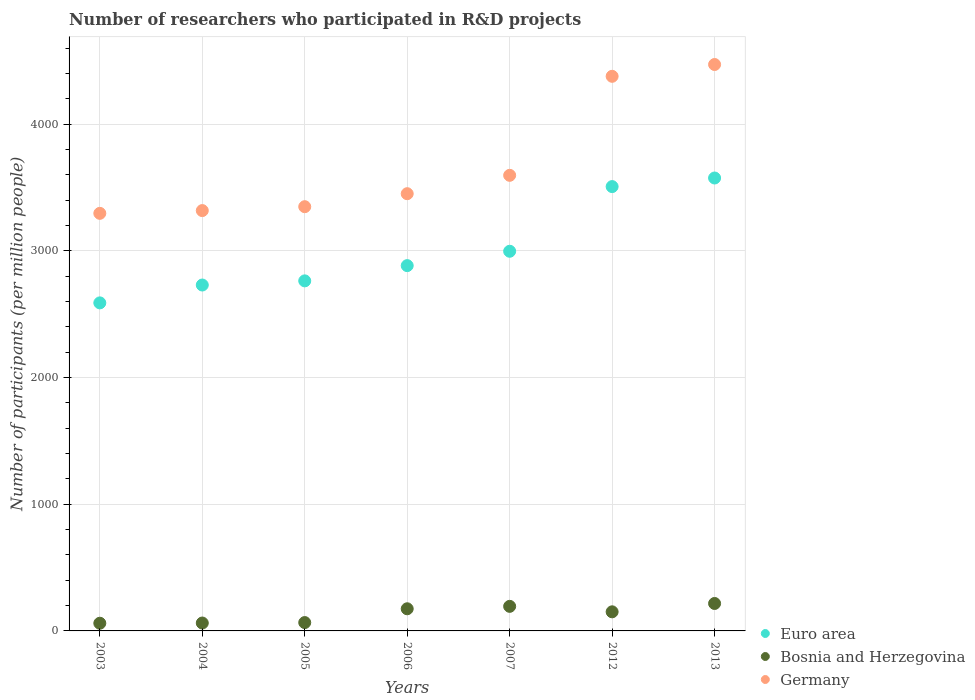Is the number of dotlines equal to the number of legend labels?
Give a very brief answer. Yes. What is the number of researchers who participated in R&D projects in Euro area in 2012?
Ensure brevity in your answer.  3508.32. Across all years, what is the maximum number of researchers who participated in R&D projects in Germany?
Make the answer very short. 4472.24. Across all years, what is the minimum number of researchers who participated in R&D projects in Euro area?
Ensure brevity in your answer.  2590.14. What is the total number of researchers who participated in R&D projects in Germany in the graph?
Your answer should be very brief. 2.59e+04. What is the difference between the number of researchers who participated in R&D projects in Bosnia and Herzegovina in 2007 and that in 2012?
Your answer should be compact. 43.24. What is the difference between the number of researchers who participated in R&D projects in Germany in 2005 and the number of researchers who participated in R&D projects in Bosnia and Herzegovina in 2012?
Offer a terse response. 3198.85. What is the average number of researchers who participated in R&D projects in Germany per year?
Your answer should be very brief. 3695.2. In the year 2005, what is the difference between the number of researchers who participated in R&D projects in Germany and number of researchers who participated in R&D projects in Euro area?
Your answer should be very brief. 585.67. In how many years, is the number of researchers who participated in R&D projects in Euro area greater than 2400?
Make the answer very short. 7. What is the ratio of the number of researchers who participated in R&D projects in Germany in 2005 to that in 2006?
Ensure brevity in your answer.  0.97. What is the difference between the highest and the second highest number of researchers who participated in R&D projects in Germany?
Keep it short and to the point. 93.17. What is the difference between the highest and the lowest number of researchers who participated in R&D projects in Euro area?
Your answer should be compact. 986.01. In how many years, is the number of researchers who participated in R&D projects in Germany greater than the average number of researchers who participated in R&D projects in Germany taken over all years?
Your answer should be compact. 2. Does the number of researchers who participated in R&D projects in Bosnia and Herzegovina monotonically increase over the years?
Your answer should be very brief. No. What is the difference between two consecutive major ticks on the Y-axis?
Provide a succinct answer. 1000. Are the values on the major ticks of Y-axis written in scientific E-notation?
Offer a very short reply. No. What is the title of the graph?
Your answer should be very brief. Number of researchers who participated in R&D projects. Does "Turks and Caicos Islands" appear as one of the legend labels in the graph?
Make the answer very short. No. What is the label or title of the X-axis?
Keep it short and to the point. Years. What is the label or title of the Y-axis?
Make the answer very short. Number of participants (per million people). What is the Number of participants (per million people) in Euro area in 2003?
Your response must be concise. 2590.14. What is the Number of participants (per million people) of Bosnia and Herzegovina in 2003?
Make the answer very short. 60.7. What is the Number of participants (per million people) of Germany in 2003?
Keep it short and to the point. 3297.09. What is the Number of participants (per million people) of Euro area in 2004?
Keep it short and to the point. 2731.18. What is the Number of participants (per million people) of Bosnia and Herzegovina in 2004?
Your answer should be compact. 62.41. What is the Number of participants (per million people) in Germany in 2004?
Provide a succinct answer. 3318.87. What is the Number of participants (per million people) in Euro area in 2005?
Offer a terse response. 2763.98. What is the Number of participants (per million people) of Bosnia and Herzegovina in 2005?
Your response must be concise. 65.95. What is the Number of participants (per million people) of Germany in 2005?
Make the answer very short. 3349.65. What is the Number of participants (per million people) of Euro area in 2006?
Make the answer very short. 2884.31. What is the Number of participants (per million people) of Bosnia and Herzegovina in 2006?
Make the answer very short. 174.84. What is the Number of participants (per million people) of Germany in 2006?
Your answer should be compact. 3452.21. What is the Number of participants (per million people) in Euro area in 2007?
Give a very brief answer. 2997.7. What is the Number of participants (per million people) of Bosnia and Herzegovina in 2007?
Make the answer very short. 194.03. What is the Number of participants (per million people) in Germany in 2007?
Provide a succinct answer. 3597.24. What is the Number of participants (per million people) in Euro area in 2012?
Give a very brief answer. 3508.32. What is the Number of participants (per million people) of Bosnia and Herzegovina in 2012?
Make the answer very short. 150.79. What is the Number of participants (per million people) in Germany in 2012?
Offer a very short reply. 4379.08. What is the Number of participants (per million people) in Euro area in 2013?
Your response must be concise. 3576.15. What is the Number of participants (per million people) of Bosnia and Herzegovina in 2013?
Provide a short and direct response. 216.68. What is the Number of participants (per million people) of Germany in 2013?
Your response must be concise. 4472.24. Across all years, what is the maximum Number of participants (per million people) of Euro area?
Make the answer very short. 3576.15. Across all years, what is the maximum Number of participants (per million people) in Bosnia and Herzegovina?
Your answer should be compact. 216.68. Across all years, what is the maximum Number of participants (per million people) of Germany?
Your response must be concise. 4472.24. Across all years, what is the minimum Number of participants (per million people) of Euro area?
Offer a very short reply. 2590.14. Across all years, what is the minimum Number of participants (per million people) in Bosnia and Herzegovina?
Offer a terse response. 60.7. Across all years, what is the minimum Number of participants (per million people) in Germany?
Keep it short and to the point. 3297.09. What is the total Number of participants (per million people) of Euro area in the graph?
Offer a terse response. 2.11e+04. What is the total Number of participants (per million people) of Bosnia and Herzegovina in the graph?
Provide a succinct answer. 925.41. What is the total Number of participants (per million people) of Germany in the graph?
Your response must be concise. 2.59e+04. What is the difference between the Number of participants (per million people) in Euro area in 2003 and that in 2004?
Keep it short and to the point. -141.05. What is the difference between the Number of participants (per million people) of Bosnia and Herzegovina in 2003 and that in 2004?
Give a very brief answer. -1.7. What is the difference between the Number of participants (per million people) of Germany in 2003 and that in 2004?
Your answer should be compact. -21.78. What is the difference between the Number of participants (per million people) of Euro area in 2003 and that in 2005?
Keep it short and to the point. -173.85. What is the difference between the Number of participants (per million people) of Bosnia and Herzegovina in 2003 and that in 2005?
Ensure brevity in your answer.  -5.25. What is the difference between the Number of participants (per million people) in Germany in 2003 and that in 2005?
Offer a terse response. -52.55. What is the difference between the Number of participants (per million people) in Euro area in 2003 and that in 2006?
Provide a succinct answer. -294.17. What is the difference between the Number of participants (per million people) in Bosnia and Herzegovina in 2003 and that in 2006?
Your response must be concise. -114.14. What is the difference between the Number of participants (per million people) of Germany in 2003 and that in 2006?
Provide a succinct answer. -155.12. What is the difference between the Number of participants (per million people) in Euro area in 2003 and that in 2007?
Ensure brevity in your answer.  -407.56. What is the difference between the Number of participants (per million people) in Bosnia and Herzegovina in 2003 and that in 2007?
Provide a short and direct response. -133.33. What is the difference between the Number of participants (per million people) in Germany in 2003 and that in 2007?
Give a very brief answer. -300.15. What is the difference between the Number of participants (per million people) in Euro area in 2003 and that in 2012?
Ensure brevity in your answer.  -918.19. What is the difference between the Number of participants (per million people) of Bosnia and Herzegovina in 2003 and that in 2012?
Keep it short and to the point. -90.09. What is the difference between the Number of participants (per million people) of Germany in 2003 and that in 2012?
Your answer should be very brief. -1081.98. What is the difference between the Number of participants (per million people) in Euro area in 2003 and that in 2013?
Your response must be concise. -986.01. What is the difference between the Number of participants (per million people) of Bosnia and Herzegovina in 2003 and that in 2013?
Make the answer very short. -155.98. What is the difference between the Number of participants (per million people) of Germany in 2003 and that in 2013?
Make the answer very short. -1175.15. What is the difference between the Number of participants (per million people) of Euro area in 2004 and that in 2005?
Offer a terse response. -32.8. What is the difference between the Number of participants (per million people) of Bosnia and Herzegovina in 2004 and that in 2005?
Provide a succinct answer. -3.55. What is the difference between the Number of participants (per million people) of Germany in 2004 and that in 2005?
Offer a terse response. -30.78. What is the difference between the Number of participants (per million people) in Euro area in 2004 and that in 2006?
Provide a short and direct response. -153.13. What is the difference between the Number of participants (per million people) of Bosnia and Herzegovina in 2004 and that in 2006?
Your answer should be very brief. -112.43. What is the difference between the Number of participants (per million people) of Germany in 2004 and that in 2006?
Your answer should be compact. -133.34. What is the difference between the Number of participants (per million people) in Euro area in 2004 and that in 2007?
Ensure brevity in your answer.  -266.52. What is the difference between the Number of participants (per million people) of Bosnia and Herzegovina in 2004 and that in 2007?
Provide a short and direct response. -131.63. What is the difference between the Number of participants (per million people) in Germany in 2004 and that in 2007?
Provide a short and direct response. -278.37. What is the difference between the Number of participants (per million people) of Euro area in 2004 and that in 2012?
Provide a short and direct response. -777.14. What is the difference between the Number of participants (per million people) of Bosnia and Herzegovina in 2004 and that in 2012?
Your answer should be compact. -88.39. What is the difference between the Number of participants (per million people) of Germany in 2004 and that in 2012?
Your answer should be compact. -1060.21. What is the difference between the Number of participants (per million people) in Euro area in 2004 and that in 2013?
Your answer should be compact. -844.96. What is the difference between the Number of participants (per million people) of Bosnia and Herzegovina in 2004 and that in 2013?
Offer a terse response. -154.28. What is the difference between the Number of participants (per million people) of Germany in 2004 and that in 2013?
Make the answer very short. -1153.37. What is the difference between the Number of participants (per million people) in Euro area in 2005 and that in 2006?
Provide a succinct answer. -120.33. What is the difference between the Number of participants (per million people) of Bosnia and Herzegovina in 2005 and that in 2006?
Give a very brief answer. -108.89. What is the difference between the Number of participants (per million people) in Germany in 2005 and that in 2006?
Give a very brief answer. -102.56. What is the difference between the Number of participants (per million people) in Euro area in 2005 and that in 2007?
Make the answer very short. -233.72. What is the difference between the Number of participants (per million people) in Bosnia and Herzegovina in 2005 and that in 2007?
Your answer should be compact. -128.08. What is the difference between the Number of participants (per million people) of Germany in 2005 and that in 2007?
Give a very brief answer. -247.59. What is the difference between the Number of participants (per million people) of Euro area in 2005 and that in 2012?
Keep it short and to the point. -744.34. What is the difference between the Number of participants (per million people) of Bosnia and Herzegovina in 2005 and that in 2012?
Your answer should be very brief. -84.84. What is the difference between the Number of participants (per million people) of Germany in 2005 and that in 2012?
Provide a succinct answer. -1029.43. What is the difference between the Number of participants (per million people) of Euro area in 2005 and that in 2013?
Keep it short and to the point. -812.16. What is the difference between the Number of participants (per million people) of Bosnia and Herzegovina in 2005 and that in 2013?
Ensure brevity in your answer.  -150.73. What is the difference between the Number of participants (per million people) of Germany in 2005 and that in 2013?
Provide a succinct answer. -1122.6. What is the difference between the Number of participants (per million people) of Euro area in 2006 and that in 2007?
Provide a short and direct response. -113.39. What is the difference between the Number of participants (per million people) of Bosnia and Herzegovina in 2006 and that in 2007?
Offer a very short reply. -19.19. What is the difference between the Number of participants (per million people) of Germany in 2006 and that in 2007?
Offer a very short reply. -145.03. What is the difference between the Number of participants (per million people) of Euro area in 2006 and that in 2012?
Your response must be concise. -624.02. What is the difference between the Number of participants (per million people) of Bosnia and Herzegovina in 2006 and that in 2012?
Your answer should be very brief. 24.05. What is the difference between the Number of participants (per million people) of Germany in 2006 and that in 2012?
Your response must be concise. -926.87. What is the difference between the Number of participants (per million people) of Euro area in 2006 and that in 2013?
Your answer should be compact. -691.84. What is the difference between the Number of participants (per million people) of Bosnia and Herzegovina in 2006 and that in 2013?
Offer a very short reply. -41.84. What is the difference between the Number of participants (per million people) in Germany in 2006 and that in 2013?
Keep it short and to the point. -1020.03. What is the difference between the Number of participants (per million people) in Euro area in 2007 and that in 2012?
Your answer should be compact. -510.63. What is the difference between the Number of participants (per million people) of Bosnia and Herzegovina in 2007 and that in 2012?
Offer a very short reply. 43.24. What is the difference between the Number of participants (per million people) in Germany in 2007 and that in 2012?
Your answer should be very brief. -781.84. What is the difference between the Number of participants (per million people) in Euro area in 2007 and that in 2013?
Keep it short and to the point. -578.45. What is the difference between the Number of participants (per million people) of Bosnia and Herzegovina in 2007 and that in 2013?
Offer a very short reply. -22.65. What is the difference between the Number of participants (per million people) in Germany in 2007 and that in 2013?
Provide a succinct answer. -875. What is the difference between the Number of participants (per million people) in Euro area in 2012 and that in 2013?
Make the answer very short. -67.82. What is the difference between the Number of participants (per million people) of Bosnia and Herzegovina in 2012 and that in 2013?
Ensure brevity in your answer.  -65.89. What is the difference between the Number of participants (per million people) in Germany in 2012 and that in 2013?
Ensure brevity in your answer.  -93.17. What is the difference between the Number of participants (per million people) in Euro area in 2003 and the Number of participants (per million people) in Bosnia and Herzegovina in 2004?
Your response must be concise. 2527.73. What is the difference between the Number of participants (per million people) of Euro area in 2003 and the Number of participants (per million people) of Germany in 2004?
Offer a very short reply. -728.73. What is the difference between the Number of participants (per million people) of Bosnia and Herzegovina in 2003 and the Number of participants (per million people) of Germany in 2004?
Offer a terse response. -3258.16. What is the difference between the Number of participants (per million people) in Euro area in 2003 and the Number of participants (per million people) in Bosnia and Herzegovina in 2005?
Your response must be concise. 2524.18. What is the difference between the Number of participants (per million people) in Euro area in 2003 and the Number of participants (per million people) in Germany in 2005?
Your response must be concise. -759.51. What is the difference between the Number of participants (per million people) of Bosnia and Herzegovina in 2003 and the Number of participants (per million people) of Germany in 2005?
Offer a terse response. -3288.94. What is the difference between the Number of participants (per million people) of Euro area in 2003 and the Number of participants (per million people) of Bosnia and Herzegovina in 2006?
Your answer should be compact. 2415.3. What is the difference between the Number of participants (per million people) in Euro area in 2003 and the Number of participants (per million people) in Germany in 2006?
Your answer should be compact. -862.07. What is the difference between the Number of participants (per million people) of Bosnia and Herzegovina in 2003 and the Number of participants (per million people) of Germany in 2006?
Provide a succinct answer. -3391.51. What is the difference between the Number of participants (per million people) in Euro area in 2003 and the Number of participants (per million people) in Bosnia and Herzegovina in 2007?
Offer a very short reply. 2396.1. What is the difference between the Number of participants (per million people) in Euro area in 2003 and the Number of participants (per million people) in Germany in 2007?
Give a very brief answer. -1007.1. What is the difference between the Number of participants (per million people) in Bosnia and Herzegovina in 2003 and the Number of participants (per million people) in Germany in 2007?
Offer a very short reply. -3536.53. What is the difference between the Number of participants (per million people) in Euro area in 2003 and the Number of participants (per million people) in Bosnia and Herzegovina in 2012?
Offer a very short reply. 2439.34. What is the difference between the Number of participants (per million people) of Euro area in 2003 and the Number of participants (per million people) of Germany in 2012?
Your answer should be very brief. -1788.94. What is the difference between the Number of participants (per million people) in Bosnia and Herzegovina in 2003 and the Number of participants (per million people) in Germany in 2012?
Provide a short and direct response. -4318.37. What is the difference between the Number of participants (per million people) in Euro area in 2003 and the Number of participants (per million people) in Bosnia and Herzegovina in 2013?
Your answer should be compact. 2373.45. What is the difference between the Number of participants (per million people) in Euro area in 2003 and the Number of participants (per million people) in Germany in 2013?
Ensure brevity in your answer.  -1882.11. What is the difference between the Number of participants (per million people) of Bosnia and Herzegovina in 2003 and the Number of participants (per million people) of Germany in 2013?
Ensure brevity in your answer.  -4411.54. What is the difference between the Number of participants (per million people) in Euro area in 2004 and the Number of participants (per million people) in Bosnia and Herzegovina in 2005?
Offer a very short reply. 2665.23. What is the difference between the Number of participants (per million people) in Euro area in 2004 and the Number of participants (per million people) in Germany in 2005?
Give a very brief answer. -618.46. What is the difference between the Number of participants (per million people) in Bosnia and Herzegovina in 2004 and the Number of participants (per million people) in Germany in 2005?
Offer a terse response. -3287.24. What is the difference between the Number of participants (per million people) of Euro area in 2004 and the Number of participants (per million people) of Bosnia and Herzegovina in 2006?
Offer a very short reply. 2556.34. What is the difference between the Number of participants (per million people) of Euro area in 2004 and the Number of participants (per million people) of Germany in 2006?
Your response must be concise. -721.03. What is the difference between the Number of participants (per million people) of Bosnia and Herzegovina in 2004 and the Number of participants (per million people) of Germany in 2006?
Give a very brief answer. -3389.8. What is the difference between the Number of participants (per million people) in Euro area in 2004 and the Number of participants (per million people) in Bosnia and Herzegovina in 2007?
Keep it short and to the point. 2537.15. What is the difference between the Number of participants (per million people) in Euro area in 2004 and the Number of participants (per million people) in Germany in 2007?
Make the answer very short. -866.06. What is the difference between the Number of participants (per million people) of Bosnia and Herzegovina in 2004 and the Number of participants (per million people) of Germany in 2007?
Make the answer very short. -3534.83. What is the difference between the Number of participants (per million people) of Euro area in 2004 and the Number of participants (per million people) of Bosnia and Herzegovina in 2012?
Provide a short and direct response. 2580.39. What is the difference between the Number of participants (per million people) of Euro area in 2004 and the Number of participants (per million people) of Germany in 2012?
Keep it short and to the point. -1647.89. What is the difference between the Number of participants (per million people) of Bosnia and Herzegovina in 2004 and the Number of participants (per million people) of Germany in 2012?
Your answer should be compact. -4316.67. What is the difference between the Number of participants (per million people) of Euro area in 2004 and the Number of participants (per million people) of Bosnia and Herzegovina in 2013?
Ensure brevity in your answer.  2514.5. What is the difference between the Number of participants (per million people) in Euro area in 2004 and the Number of participants (per million people) in Germany in 2013?
Offer a terse response. -1741.06. What is the difference between the Number of participants (per million people) of Bosnia and Herzegovina in 2004 and the Number of participants (per million people) of Germany in 2013?
Make the answer very short. -4409.84. What is the difference between the Number of participants (per million people) in Euro area in 2005 and the Number of participants (per million people) in Bosnia and Herzegovina in 2006?
Make the answer very short. 2589.14. What is the difference between the Number of participants (per million people) of Euro area in 2005 and the Number of participants (per million people) of Germany in 2006?
Ensure brevity in your answer.  -688.23. What is the difference between the Number of participants (per million people) in Bosnia and Herzegovina in 2005 and the Number of participants (per million people) in Germany in 2006?
Provide a succinct answer. -3386.26. What is the difference between the Number of participants (per million people) of Euro area in 2005 and the Number of participants (per million people) of Bosnia and Herzegovina in 2007?
Keep it short and to the point. 2569.95. What is the difference between the Number of participants (per million people) in Euro area in 2005 and the Number of participants (per million people) in Germany in 2007?
Your answer should be compact. -833.26. What is the difference between the Number of participants (per million people) in Bosnia and Herzegovina in 2005 and the Number of participants (per million people) in Germany in 2007?
Offer a very short reply. -3531.29. What is the difference between the Number of participants (per million people) of Euro area in 2005 and the Number of participants (per million people) of Bosnia and Herzegovina in 2012?
Provide a short and direct response. 2613.19. What is the difference between the Number of participants (per million people) of Euro area in 2005 and the Number of participants (per million people) of Germany in 2012?
Make the answer very short. -1615.09. What is the difference between the Number of participants (per million people) of Bosnia and Herzegovina in 2005 and the Number of participants (per million people) of Germany in 2012?
Your response must be concise. -4313.12. What is the difference between the Number of participants (per million people) in Euro area in 2005 and the Number of participants (per million people) in Bosnia and Herzegovina in 2013?
Offer a very short reply. 2547.3. What is the difference between the Number of participants (per million people) of Euro area in 2005 and the Number of participants (per million people) of Germany in 2013?
Give a very brief answer. -1708.26. What is the difference between the Number of participants (per million people) in Bosnia and Herzegovina in 2005 and the Number of participants (per million people) in Germany in 2013?
Offer a terse response. -4406.29. What is the difference between the Number of participants (per million people) of Euro area in 2006 and the Number of participants (per million people) of Bosnia and Herzegovina in 2007?
Your answer should be compact. 2690.27. What is the difference between the Number of participants (per million people) in Euro area in 2006 and the Number of participants (per million people) in Germany in 2007?
Your response must be concise. -712.93. What is the difference between the Number of participants (per million people) in Bosnia and Herzegovina in 2006 and the Number of participants (per million people) in Germany in 2007?
Your answer should be very brief. -3422.4. What is the difference between the Number of participants (per million people) in Euro area in 2006 and the Number of participants (per million people) in Bosnia and Herzegovina in 2012?
Your answer should be very brief. 2733.51. What is the difference between the Number of participants (per million people) in Euro area in 2006 and the Number of participants (per million people) in Germany in 2012?
Keep it short and to the point. -1494.77. What is the difference between the Number of participants (per million people) of Bosnia and Herzegovina in 2006 and the Number of participants (per million people) of Germany in 2012?
Provide a succinct answer. -4204.24. What is the difference between the Number of participants (per million people) of Euro area in 2006 and the Number of participants (per million people) of Bosnia and Herzegovina in 2013?
Make the answer very short. 2667.62. What is the difference between the Number of participants (per million people) of Euro area in 2006 and the Number of participants (per million people) of Germany in 2013?
Offer a very short reply. -1587.93. What is the difference between the Number of participants (per million people) in Bosnia and Herzegovina in 2006 and the Number of participants (per million people) in Germany in 2013?
Ensure brevity in your answer.  -4297.4. What is the difference between the Number of participants (per million people) in Euro area in 2007 and the Number of participants (per million people) in Bosnia and Herzegovina in 2012?
Make the answer very short. 2846.9. What is the difference between the Number of participants (per million people) in Euro area in 2007 and the Number of participants (per million people) in Germany in 2012?
Your answer should be very brief. -1381.38. What is the difference between the Number of participants (per million people) of Bosnia and Herzegovina in 2007 and the Number of participants (per million people) of Germany in 2012?
Ensure brevity in your answer.  -4185.04. What is the difference between the Number of participants (per million people) of Euro area in 2007 and the Number of participants (per million people) of Bosnia and Herzegovina in 2013?
Keep it short and to the point. 2781.01. What is the difference between the Number of participants (per million people) in Euro area in 2007 and the Number of participants (per million people) in Germany in 2013?
Give a very brief answer. -1474.54. What is the difference between the Number of participants (per million people) in Bosnia and Herzegovina in 2007 and the Number of participants (per million people) in Germany in 2013?
Your answer should be compact. -4278.21. What is the difference between the Number of participants (per million people) in Euro area in 2012 and the Number of participants (per million people) in Bosnia and Herzegovina in 2013?
Make the answer very short. 3291.64. What is the difference between the Number of participants (per million people) of Euro area in 2012 and the Number of participants (per million people) of Germany in 2013?
Keep it short and to the point. -963.92. What is the difference between the Number of participants (per million people) in Bosnia and Herzegovina in 2012 and the Number of participants (per million people) in Germany in 2013?
Make the answer very short. -4321.45. What is the average Number of participants (per million people) of Euro area per year?
Make the answer very short. 3007.4. What is the average Number of participants (per million people) in Bosnia and Herzegovina per year?
Your answer should be very brief. 132.2. What is the average Number of participants (per million people) of Germany per year?
Offer a terse response. 3695.2. In the year 2003, what is the difference between the Number of participants (per million people) of Euro area and Number of participants (per million people) of Bosnia and Herzegovina?
Provide a short and direct response. 2529.43. In the year 2003, what is the difference between the Number of participants (per million people) in Euro area and Number of participants (per million people) in Germany?
Offer a very short reply. -706.96. In the year 2003, what is the difference between the Number of participants (per million people) in Bosnia and Herzegovina and Number of participants (per million people) in Germany?
Provide a succinct answer. -3236.39. In the year 2004, what is the difference between the Number of participants (per million people) of Euro area and Number of participants (per million people) of Bosnia and Herzegovina?
Give a very brief answer. 2668.78. In the year 2004, what is the difference between the Number of participants (per million people) in Euro area and Number of participants (per million people) in Germany?
Provide a succinct answer. -587.69. In the year 2004, what is the difference between the Number of participants (per million people) of Bosnia and Herzegovina and Number of participants (per million people) of Germany?
Give a very brief answer. -3256.46. In the year 2005, what is the difference between the Number of participants (per million people) in Euro area and Number of participants (per million people) in Bosnia and Herzegovina?
Ensure brevity in your answer.  2698.03. In the year 2005, what is the difference between the Number of participants (per million people) in Euro area and Number of participants (per million people) in Germany?
Keep it short and to the point. -585.67. In the year 2005, what is the difference between the Number of participants (per million people) in Bosnia and Herzegovina and Number of participants (per million people) in Germany?
Your response must be concise. -3283.7. In the year 2006, what is the difference between the Number of participants (per million people) in Euro area and Number of participants (per million people) in Bosnia and Herzegovina?
Keep it short and to the point. 2709.47. In the year 2006, what is the difference between the Number of participants (per million people) in Euro area and Number of participants (per million people) in Germany?
Make the answer very short. -567.9. In the year 2006, what is the difference between the Number of participants (per million people) in Bosnia and Herzegovina and Number of participants (per million people) in Germany?
Ensure brevity in your answer.  -3277.37. In the year 2007, what is the difference between the Number of participants (per million people) in Euro area and Number of participants (per million people) in Bosnia and Herzegovina?
Provide a succinct answer. 2803.66. In the year 2007, what is the difference between the Number of participants (per million people) in Euro area and Number of participants (per million people) in Germany?
Ensure brevity in your answer.  -599.54. In the year 2007, what is the difference between the Number of participants (per million people) in Bosnia and Herzegovina and Number of participants (per million people) in Germany?
Your response must be concise. -3403.21. In the year 2012, what is the difference between the Number of participants (per million people) of Euro area and Number of participants (per million people) of Bosnia and Herzegovina?
Offer a very short reply. 3357.53. In the year 2012, what is the difference between the Number of participants (per million people) of Euro area and Number of participants (per million people) of Germany?
Provide a short and direct response. -870.75. In the year 2012, what is the difference between the Number of participants (per million people) in Bosnia and Herzegovina and Number of participants (per million people) in Germany?
Your answer should be compact. -4228.28. In the year 2013, what is the difference between the Number of participants (per million people) in Euro area and Number of participants (per million people) in Bosnia and Herzegovina?
Your answer should be very brief. 3359.46. In the year 2013, what is the difference between the Number of participants (per million people) in Euro area and Number of participants (per million people) in Germany?
Offer a terse response. -896.1. In the year 2013, what is the difference between the Number of participants (per million people) of Bosnia and Herzegovina and Number of participants (per million people) of Germany?
Your response must be concise. -4255.56. What is the ratio of the Number of participants (per million people) of Euro area in 2003 to that in 2004?
Your answer should be very brief. 0.95. What is the ratio of the Number of participants (per million people) of Bosnia and Herzegovina in 2003 to that in 2004?
Keep it short and to the point. 0.97. What is the ratio of the Number of participants (per million people) in Euro area in 2003 to that in 2005?
Keep it short and to the point. 0.94. What is the ratio of the Number of participants (per million people) of Bosnia and Herzegovina in 2003 to that in 2005?
Provide a short and direct response. 0.92. What is the ratio of the Number of participants (per million people) of Germany in 2003 to that in 2005?
Ensure brevity in your answer.  0.98. What is the ratio of the Number of participants (per million people) in Euro area in 2003 to that in 2006?
Keep it short and to the point. 0.9. What is the ratio of the Number of participants (per million people) of Bosnia and Herzegovina in 2003 to that in 2006?
Provide a short and direct response. 0.35. What is the ratio of the Number of participants (per million people) in Germany in 2003 to that in 2006?
Give a very brief answer. 0.96. What is the ratio of the Number of participants (per million people) in Euro area in 2003 to that in 2007?
Ensure brevity in your answer.  0.86. What is the ratio of the Number of participants (per million people) of Bosnia and Herzegovina in 2003 to that in 2007?
Your answer should be very brief. 0.31. What is the ratio of the Number of participants (per million people) of Germany in 2003 to that in 2007?
Provide a short and direct response. 0.92. What is the ratio of the Number of participants (per million people) in Euro area in 2003 to that in 2012?
Your answer should be compact. 0.74. What is the ratio of the Number of participants (per million people) of Bosnia and Herzegovina in 2003 to that in 2012?
Provide a succinct answer. 0.4. What is the ratio of the Number of participants (per million people) of Germany in 2003 to that in 2012?
Provide a succinct answer. 0.75. What is the ratio of the Number of participants (per million people) in Euro area in 2003 to that in 2013?
Ensure brevity in your answer.  0.72. What is the ratio of the Number of participants (per million people) of Bosnia and Herzegovina in 2003 to that in 2013?
Your answer should be compact. 0.28. What is the ratio of the Number of participants (per million people) in Germany in 2003 to that in 2013?
Your answer should be very brief. 0.74. What is the ratio of the Number of participants (per million people) in Euro area in 2004 to that in 2005?
Keep it short and to the point. 0.99. What is the ratio of the Number of participants (per million people) of Bosnia and Herzegovina in 2004 to that in 2005?
Your answer should be very brief. 0.95. What is the ratio of the Number of participants (per million people) of Germany in 2004 to that in 2005?
Give a very brief answer. 0.99. What is the ratio of the Number of participants (per million people) of Euro area in 2004 to that in 2006?
Your response must be concise. 0.95. What is the ratio of the Number of participants (per million people) in Bosnia and Herzegovina in 2004 to that in 2006?
Your answer should be very brief. 0.36. What is the ratio of the Number of participants (per million people) in Germany in 2004 to that in 2006?
Provide a short and direct response. 0.96. What is the ratio of the Number of participants (per million people) in Euro area in 2004 to that in 2007?
Make the answer very short. 0.91. What is the ratio of the Number of participants (per million people) of Bosnia and Herzegovina in 2004 to that in 2007?
Ensure brevity in your answer.  0.32. What is the ratio of the Number of participants (per million people) in Germany in 2004 to that in 2007?
Offer a very short reply. 0.92. What is the ratio of the Number of participants (per million people) of Euro area in 2004 to that in 2012?
Provide a succinct answer. 0.78. What is the ratio of the Number of participants (per million people) of Bosnia and Herzegovina in 2004 to that in 2012?
Make the answer very short. 0.41. What is the ratio of the Number of participants (per million people) in Germany in 2004 to that in 2012?
Keep it short and to the point. 0.76. What is the ratio of the Number of participants (per million people) of Euro area in 2004 to that in 2013?
Your answer should be compact. 0.76. What is the ratio of the Number of participants (per million people) of Bosnia and Herzegovina in 2004 to that in 2013?
Make the answer very short. 0.29. What is the ratio of the Number of participants (per million people) of Germany in 2004 to that in 2013?
Make the answer very short. 0.74. What is the ratio of the Number of participants (per million people) of Euro area in 2005 to that in 2006?
Your answer should be very brief. 0.96. What is the ratio of the Number of participants (per million people) in Bosnia and Herzegovina in 2005 to that in 2006?
Your answer should be very brief. 0.38. What is the ratio of the Number of participants (per million people) in Germany in 2005 to that in 2006?
Offer a terse response. 0.97. What is the ratio of the Number of participants (per million people) in Euro area in 2005 to that in 2007?
Make the answer very short. 0.92. What is the ratio of the Number of participants (per million people) in Bosnia and Herzegovina in 2005 to that in 2007?
Offer a terse response. 0.34. What is the ratio of the Number of participants (per million people) in Germany in 2005 to that in 2007?
Your response must be concise. 0.93. What is the ratio of the Number of participants (per million people) of Euro area in 2005 to that in 2012?
Your response must be concise. 0.79. What is the ratio of the Number of participants (per million people) in Bosnia and Herzegovina in 2005 to that in 2012?
Give a very brief answer. 0.44. What is the ratio of the Number of participants (per million people) of Germany in 2005 to that in 2012?
Offer a terse response. 0.76. What is the ratio of the Number of participants (per million people) of Euro area in 2005 to that in 2013?
Ensure brevity in your answer.  0.77. What is the ratio of the Number of participants (per million people) in Bosnia and Herzegovina in 2005 to that in 2013?
Offer a very short reply. 0.3. What is the ratio of the Number of participants (per million people) in Germany in 2005 to that in 2013?
Your response must be concise. 0.75. What is the ratio of the Number of participants (per million people) in Euro area in 2006 to that in 2007?
Your response must be concise. 0.96. What is the ratio of the Number of participants (per million people) of Bosnia and Herzegovina in 2006 to that in 2007?
Your answer should be very brief. 0.9. What is the ratio of the Number of participants (per million people) in Germany in 2006 to that in 2007?
Your answer should be compact. 0.96. What is the ratio of the Number of participants (per million people) in Euro area in 2006 to that in 2012?
Give a very brief answer. 0.82. What is the ratio of the Number of participants (per million people) in Bosnia and Herzegovina in 2006 to that in 2012?
Your answer should be compact. 1.16. What is the ratio of the Number of participants (per million people) in Germany in 2006 to that in 2012?
Offer a terse response. 0.79. What is the ratio of the Number of participants (per million people) in Euro area in 2006 to that in 2013?
Offer a very short reply. 0.81. What is the ratio of the Number of participants (per million people) in Bosnia and Herzegovina in 2006 to that in 2013?
Keep it short and to the point. 0.81. What is the ratio of the Number of participants (per million people) of Germany in 2006 to that in 2013?
Provide a short and direct response. 0.77. What is the ratio of the Number of participants (per million people) of Euro area in 2007 to that in 2012?
Give a very brief answer. 0.85. What is the ratio of the Number of participants (per million people) in Bosnia and Herzegovina in 2007 to that in 2012?
Ensure brevity in your answer.  1.29. What is the ratio of the Number of participants (per million people) of Germany in 2007 to that in 2012?
Provide a short and direct response. 0.82. What is the ratio of the Number of participants (per million people) in Euro area in 2007 to that in 2013?
Your answer should be compact. 0.84. What is the ratio of the Number of participants (per million people) in Bosnia and Herzegovina in 2007 to that in 2013?
Your answer should be compact. 0.9. What is the ratio of the Number of participants (per million people) of Germany in 2007 to that in 2013?
Provide a succinct answer. 0.8. What is the ratio of the Number of participants (per million people) of Euro area in 2012 to that in 2013?
Keep it short and to the point. 0.98. What is the ratio of the Number of participants (per million people) of Bosnia and Herzegovina in 2012 to that in 2013?
Your answer should be compact. 0.7. What is the ratio of the Number of participants (per million people) in Germany in 2012 to that in 2013?
Ensure brevity in your answer.  0.98. What is the difference between the highest and the second highest Number of participants (per million people) of Euro area?
Ensure brevity in your answer.  67.82. What is the difference between the highest and the second highest Number of participants (per million people) in Bosnia and Herzegovina?
Give a very brief answer. 22.65. What is the difference between the highest and the second highest Number of participants (per million people) of Germany?
Make the answer very short. 93.17. What is the difference between the highest and the lowest Number of participants (per million people) in Euro area?
Your response must be concise. 986.01. What is the difference between the highest and the lowest Number of participants (per million people) of Bosnia and Herzegovina?
Your answer should be very brief. 155.98. What is the difference between the highest and the lowest Number of participants (per million people) of Germany?
Offer a terse response. 1175.15. 